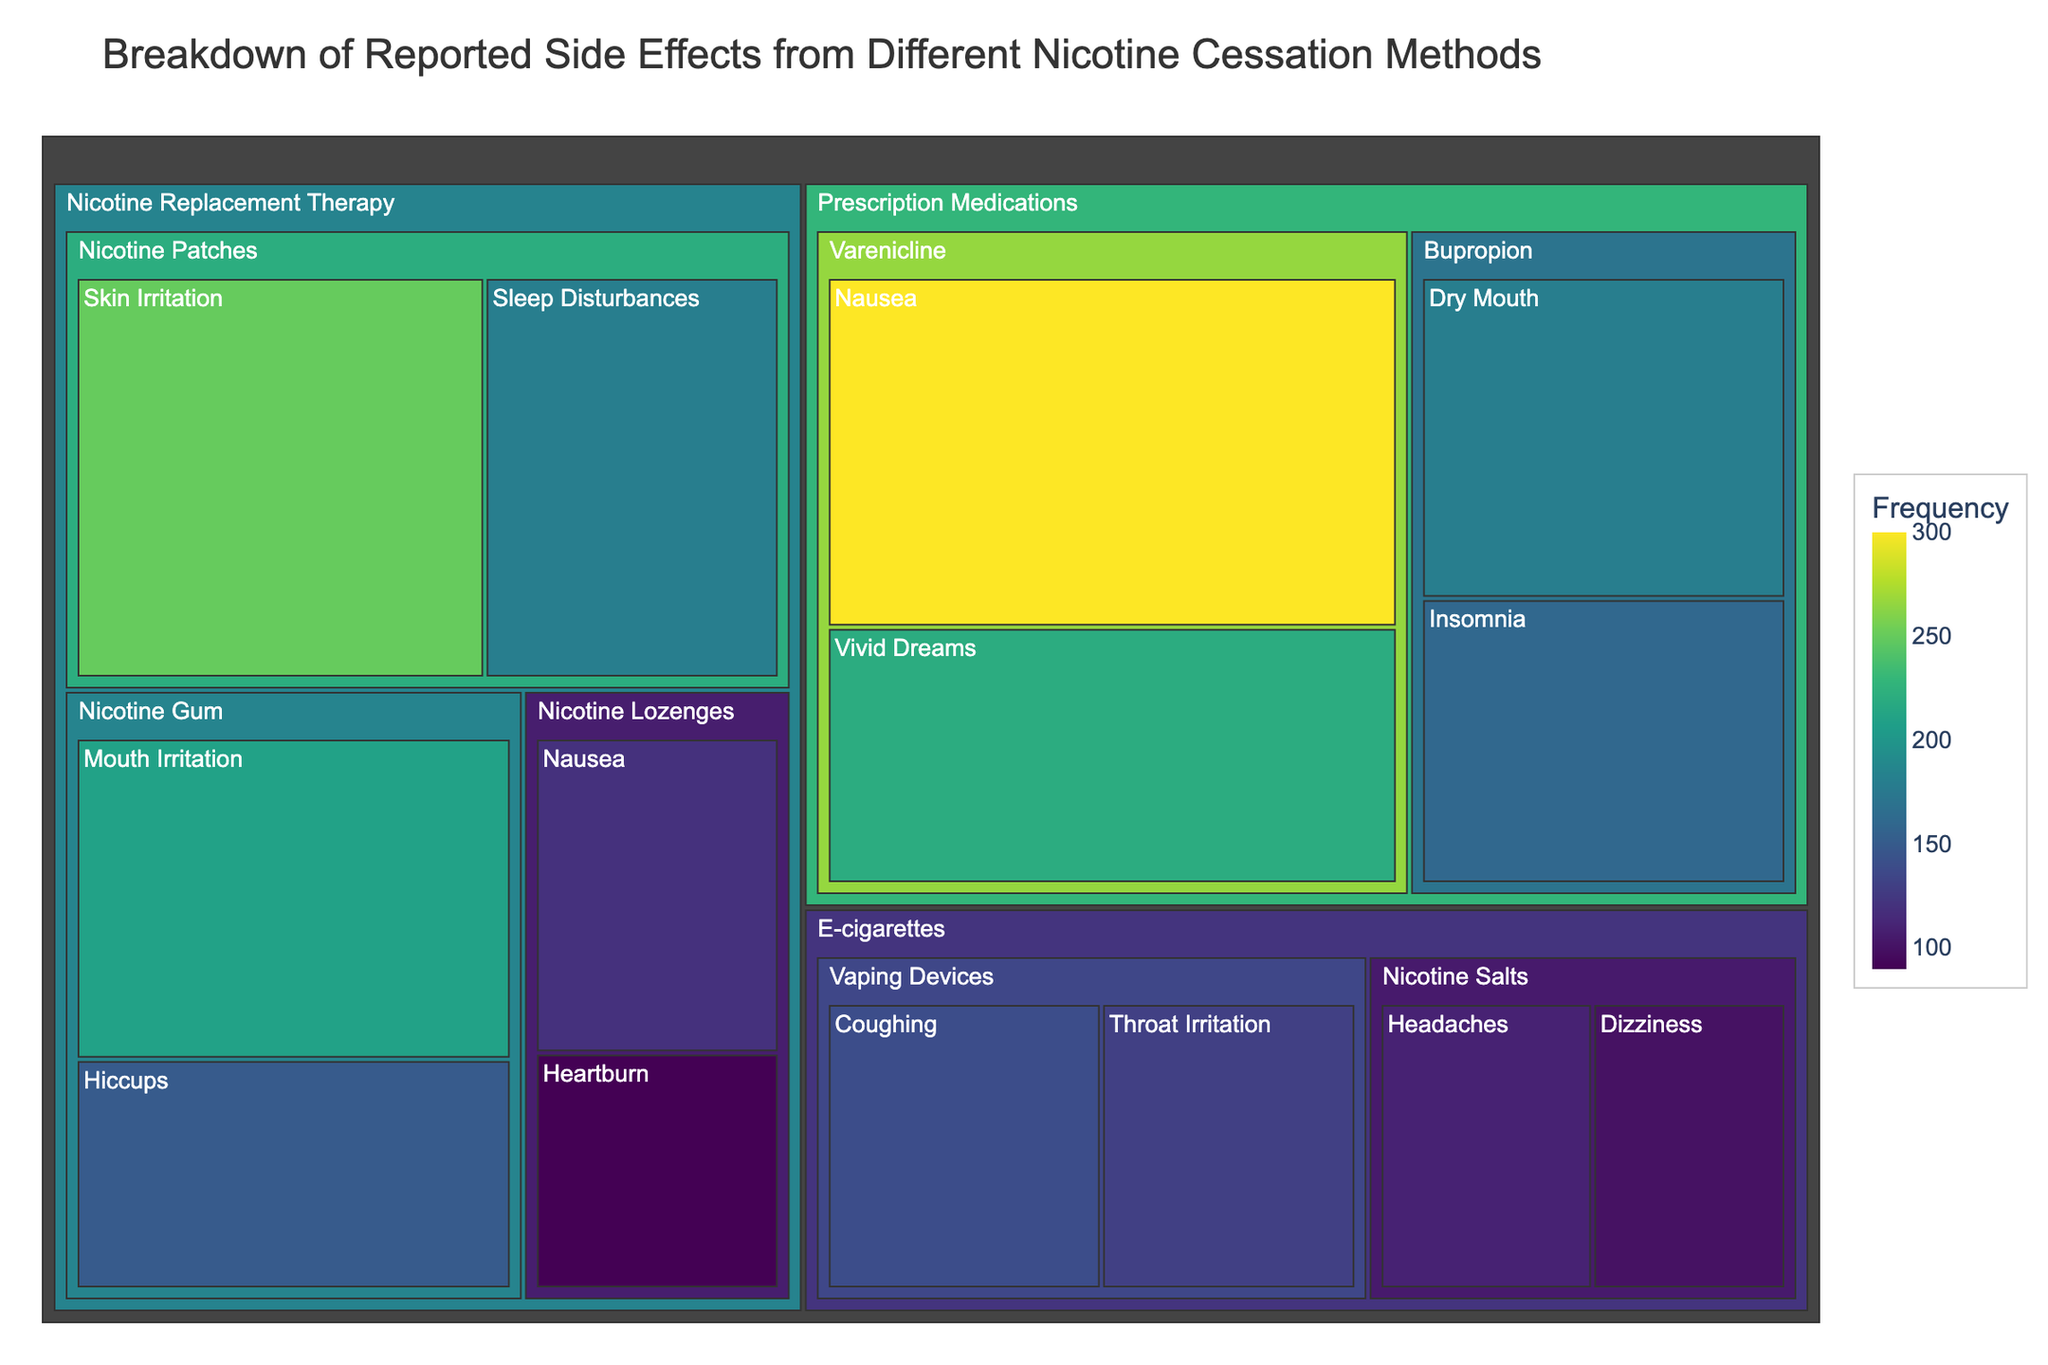What's the most common side effect reported for nicotine patches? Locate the section for "Nicotine Replacement Therapy" and within it, find "Nicotine Patches". Compare the frequencies of side effects associated with nicotine patches: Skin Irritation (250) and Sleep Disturbances (180). Skin Irritation has the highest frequency.
Answer: Skin Irritation Which category shows the highest frequency for nausea? Look for all instances of nausea across different categories: NRT (Nicotine Lozenges - 120) and Prescription Medications (Varenicline - 300). Varenicline has the highest frequency.
Answer: Prescription Medications What is the total frequency of side effects reported for vaping devices? Identify the frequencies under "E-cigarettes" -> "Vaping Devices": Coughing (140) and Throat Irritation (130). Sum these frequencies: 140 + 130 = 270.
Answer: 270 Comparing nicotine gum and nicotine lozenges, which method has more reported side effects? Sum the frequencies for each method: Nicotine Gum: Mouth Irritation (210) + Hiccups (150) = 360; Nicotine Lozenges: Nausea (120) + Heartburn (90) = 210. Nicotine Gum has more reported side effects.
Answer: Nicotine Gum Which side effect has the lowest frequency among all reported side effects? Identify the lowest numerical value for frequency in the figure: 90 for Heartburn from Nicotine Lozenges.
Answer: Heartburn How does the frequency of sleep disturbances from nicotine patches compare to the frequency of insomnia from bupropion? Locate the frequencies for "Sleep Disturbances" under "Nicotine Patches" (180) and "Insomnia" under "Bupropion" (160). Compare the numbers: 180 is greater than 160.
Answer: Sleep Disturbances is higher What's the total frequency of side effects reported in the Prescription Medications category? Sum the frequencies for all methods under "Prescription Medications": Varenicline: Nausea (300) + Vivid Dreams (220); Bupropion: Dry Mouth (180) + Insomnia (160). 300 + 220 + 180 + 160 = 860.
Answer: 860 What are the two most common side effects across all nicotine cessation methods? Identify the two highest frequency values across the entire figure: Varenicline - Nausea (300) and Varenicline - Vivid Dreams (220).
Answer: Nausea and Vivid Dreams 